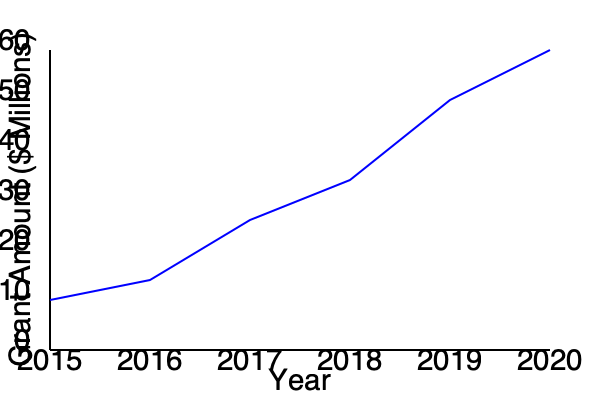Based on the trend shown in the line graph, what is the estimated percentage increase in medical education grant amounts from 2015 to 2020? Additionally, what implications might this trend have for future grant targeting strategies? To answer this question, we need to follow these steps:

1. Identify the grant amounts for 2015 and 2020:
   - 2015: Approximately $10 million
   - 2020: Approximately $55 million

2. Calculate the percentage increase:
   Percentage increase = $\frac{\text{Increase}}{\text{Original Amount}} \times 100\%$
   $= \frac{55 - 10}{10} \times 100\% = \frac{45}{10} \times 100\% = 450\%$

3. Implications for future grant targeting strategies:
   a) The significant increase (450%) suggests a growing emphasis on medical education funding.
   b) This trend may indicate a need for more sophisticated and larger-scale projects in medical education.
   c) Competition for grants may increase, requiring more innovative and impactful proposals.
   d) There may be opportunities to target specific areas within medical education that are driving this growth.
   e) Institutions might need to enhance their infrastructure and capacity to manage larger grants.
   f) Researchers should stay informed about emerging priorities in medical education to align their proposals with funders' interests.
   g) Collaboration between institutions may become more important to leverage resources and expertise for larger projects.
Answer: 450% increase; implications include increased competition, need for larger-scale projects, and emphasis on innovative approaches in medical education grant proposals. 